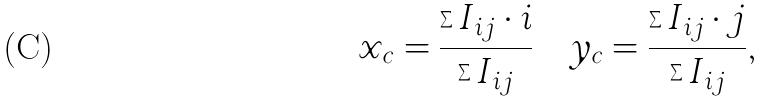Convert formula to latex. <formula><loc_0><loc_0><loc_500><loc_500>x _ { c } = \frac { \sum I _ { i j } \cdot i } { \sum I _ { i j } } \quad y _ { c } = \frac { \sum I _ { i j } \cdot j } { \sum I _ { i j } } ,</formula> 